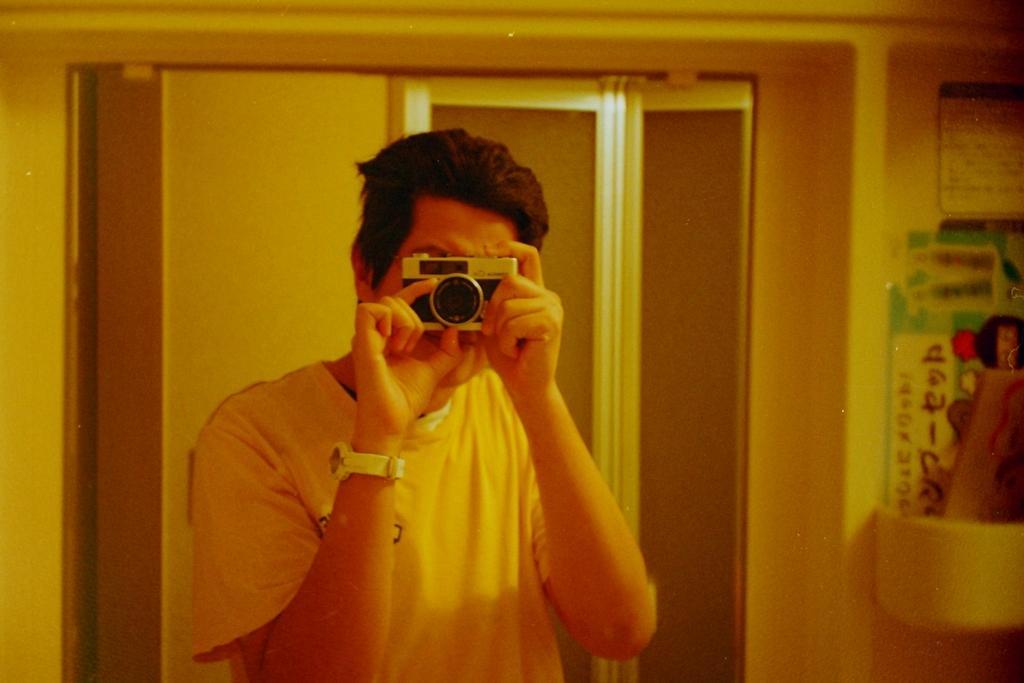Describe this image in one or two sentences. In this image I can see a person holding the camera. In the background there are boards attached to the wall. 